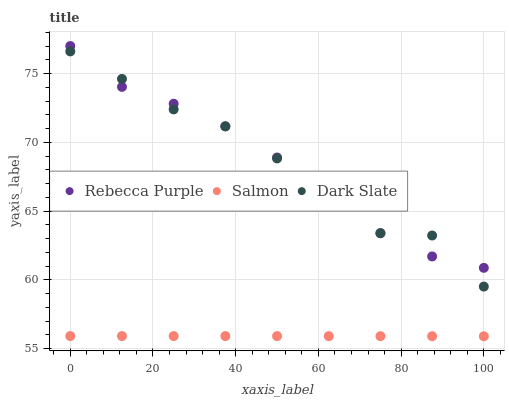Does Salmon have the minimum area under the curve?
Answer yes or no. Yes. Does Dark Slate have the maximum area under the curve?
Answer yes or no. Yes. Does Rebecca Purple have the minimum area under the curve?
Answer yes or no. No. Does Rebecca Purple have the maximum area under the curve?
Answer yes or no. No. Is Salmon the smoothest?
Answer yes or no. Yes. Is Dark Slate the roughest?
Answer yes or no. Yes. Is Rebecca Purple the smoothest?
Answer yes or no. No. Is Rebecca Purple the roughest?
Answer yes or no. No. Does Salmon have the lowest value?
Answer yes or no. Yes. Does Rebecca Purple have the lowest value?
Answer yes or no. No. Does Rebecca Purple have the highest value?
Answer yes or no. Yes. Does Salmon have the highest value?
Answer yes or no. No. Is Salmon less than Rebecca Purple?
Answer yes or no. Yes. Is Dark Slate greater than Salmon?
Answer yes or no. Yes. Does Dark Slate intersect Rebecca Purple?
Answer yes or no. Yes. Is Dark Slate less than Rebecca Purple?
Answer yes or no. No. Is Dark Slate greater than Rebecca Purple?
Answer yes or no. No. Does Salmon intersect Rebecca Purple?
Answer yes or no. No. 